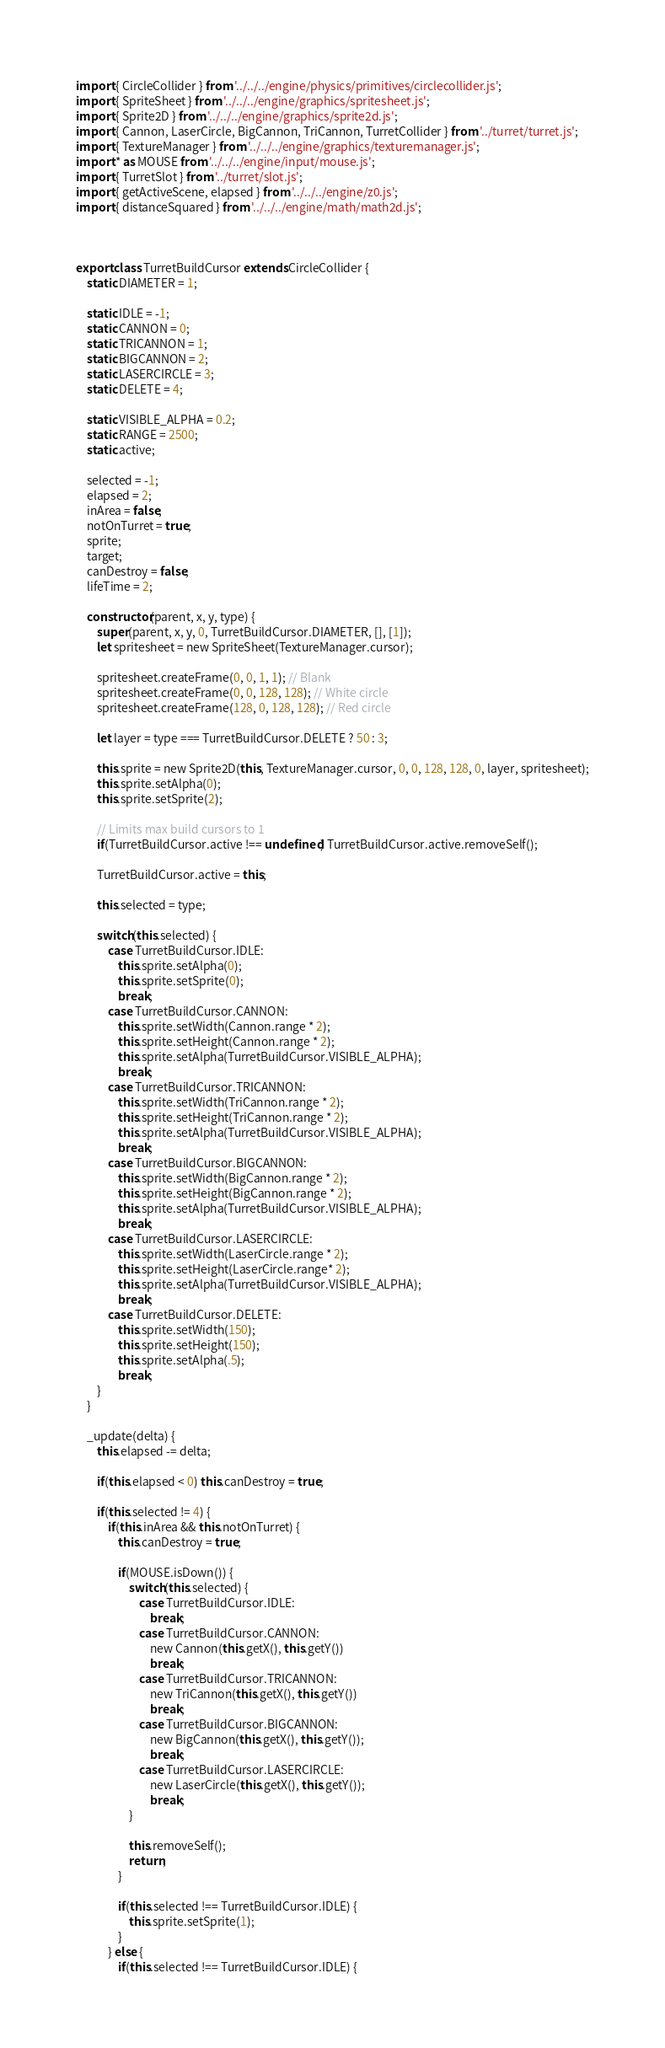Convert code to text. <code><loc_0><loc_0><loc_500><loc_500><_JavaScript_>import { CircleCollider } from '../../../engine/physics/primitives/circlecollider.js';
import { SpriteSheet } from '../../../engine/graphics/spritesheet.js';
import { Sprite2D } from '../../../engine/graphics/sprite2d.js';
import { Cannon, LaserCircle, BigCannon, TriCannon, TurretCollider } from '../turret/turret.js';
import { TextureManager } from '../../../engine/graphics/texturemanager.js';
import * as MOUSE from '../../../engine/input/mouse.js';
import { TurretSlot } from '../turret/slot.js';
import { getActiveScene, elapsed } from '../../../engine/z0.js';
import { distanceSquared } from '../../../engine/math/math2d.js';



export class TurretBuildCursor extends CircleCollider {
    static DIAMETER = 1;

    static IDLE = -1;
    static CANNON = 0;
    static TRICANNON = 1;
    static BIGCANNON = 2;
    static LASERCIRCLE = 3;
    static DELETE = 4;

    static VISIBLE_ALPHA = 0.2;
    static RANGE = 2500;
    static active;

    selected = -1;
    elapsed = 2;
    inArea = false;
    notOnTurret = true;
    sprite;
    target;
    canDestroy = false;
    lifeTime = 2;

    constructor(parent, x, y, type) {
        super(parent, x, y, 0, TurretBuildCursor.DIAMETER, [], [1]);
        let spritesheet = new SpriteSheet(TextureManager.cursor);

        spritesheet.createFrame(0, 0, 1, 1); // Blank
        spritesheet.createFrame(0, 0, 128, 128); // White circle
        spritesheet.createFrame(128, 0, 128, 128); // Red circle

        let layer = type === TurretBuildCursor.DELETE ? 50 : 3;

        this.sprite = new Sprite2D(this, TextureManager.cursor, 0, 0, 128, 128, 0, layer, spritesheet);
        this.sprite.setAlpha(0);
        this.sprite.setSprite(2);

        // Limits max build cursors to 1
        if(TurretBuildCursor.active !== undefined) TurretBuildCursor.active.removeSelf();

        TurretBuildCursor.active = this;

        this.selected = type;

        switch(this.selected) {
            case TurretBuildCursor.IDLE:
                this.sprite.setAlpha(0);
                this.sprite.setSprite(0);
                break;
            case TurretBuildCursor.CANNON:
                this.sprite.setWidth(Cannon.range * 2);
                this.sprite.setHeight(Cannon.range * 2);
                this.sprite.setAlpha(TurretBuildCursor.VISIBLE_ALPHA);
                break;
            case TurretBuildCursor.TRICANNON:
                this.sprite.setWidth(TriCannon.range * 2);
                this.sprite.setHeight(TriCannon.range * 2);
                this.sprite.setAlpha(TurretBuildCursor.VISIBLE_ALPHA);
                break;
            case TurretBuildCursor.BIGCANNON:
                this.sprite.setWidth(BigCannon.range * 2);
                this.sprite.setHeight(BigCannon.range * 2);
                this.sprite.setAlpha(TurretBuildCursor.VISIBLE_ALPHA);
                break;
            case TurretBuildCursor.LASERCIRCLE:
                this.sprite.setWidth(LaserCircle.range * 2);
                this.sprite.setHeight(LaserCircle.range* 2);
                this.sprite.setAlpha(TurretBuildCursor.VISIBLE_ALPHA);
                break;
            case TurretBuildCursor.DELETE:
                this.sprite.setWidth(150);
                this.sprite.setHeight(150);
                this.sprite.setAlpha(.5);
                break;
        }
    }

    _update(delta) {
        this.elapsed -= delta;

        if(this.elapsed < 0) this.canDestroy = true;

        if(this.selected != 4) {
            if(this.inArea && this.notOnTurret) {
                this.canDestroy = true;

                if(MOUSE.isDown()) {
                    switch(this.selected) {
                        case TurretBuildCursor.IDLE:
                            break;
                        case TurretBuildCursor.CANNON:
                            new Cannon(this.getX(), this.getY())
                            break;
                        case TurretBuildCursor.TRICANNON:
                            new TriCannon(this.getX(), this.getY())
                            break;
                        case TurretBuildCursor.BIGCANNON:
                            new BigCannon(this.getX(), this.getY());
                            break;
                        case TurretBuildCursor.LASERCIRCLE:
                            new LaserCircle(this.getX(), this.getY());
                            break;
                    }

                    this.removeSelf();
                    return;
                }

                if(this.selected !== TurretBuildCursor.IDLE) {
                    this.sprite.setSprite(1);
                }
            } else {
                if(this.selected !== TurretBuildCursor.IDLE) {</code> 